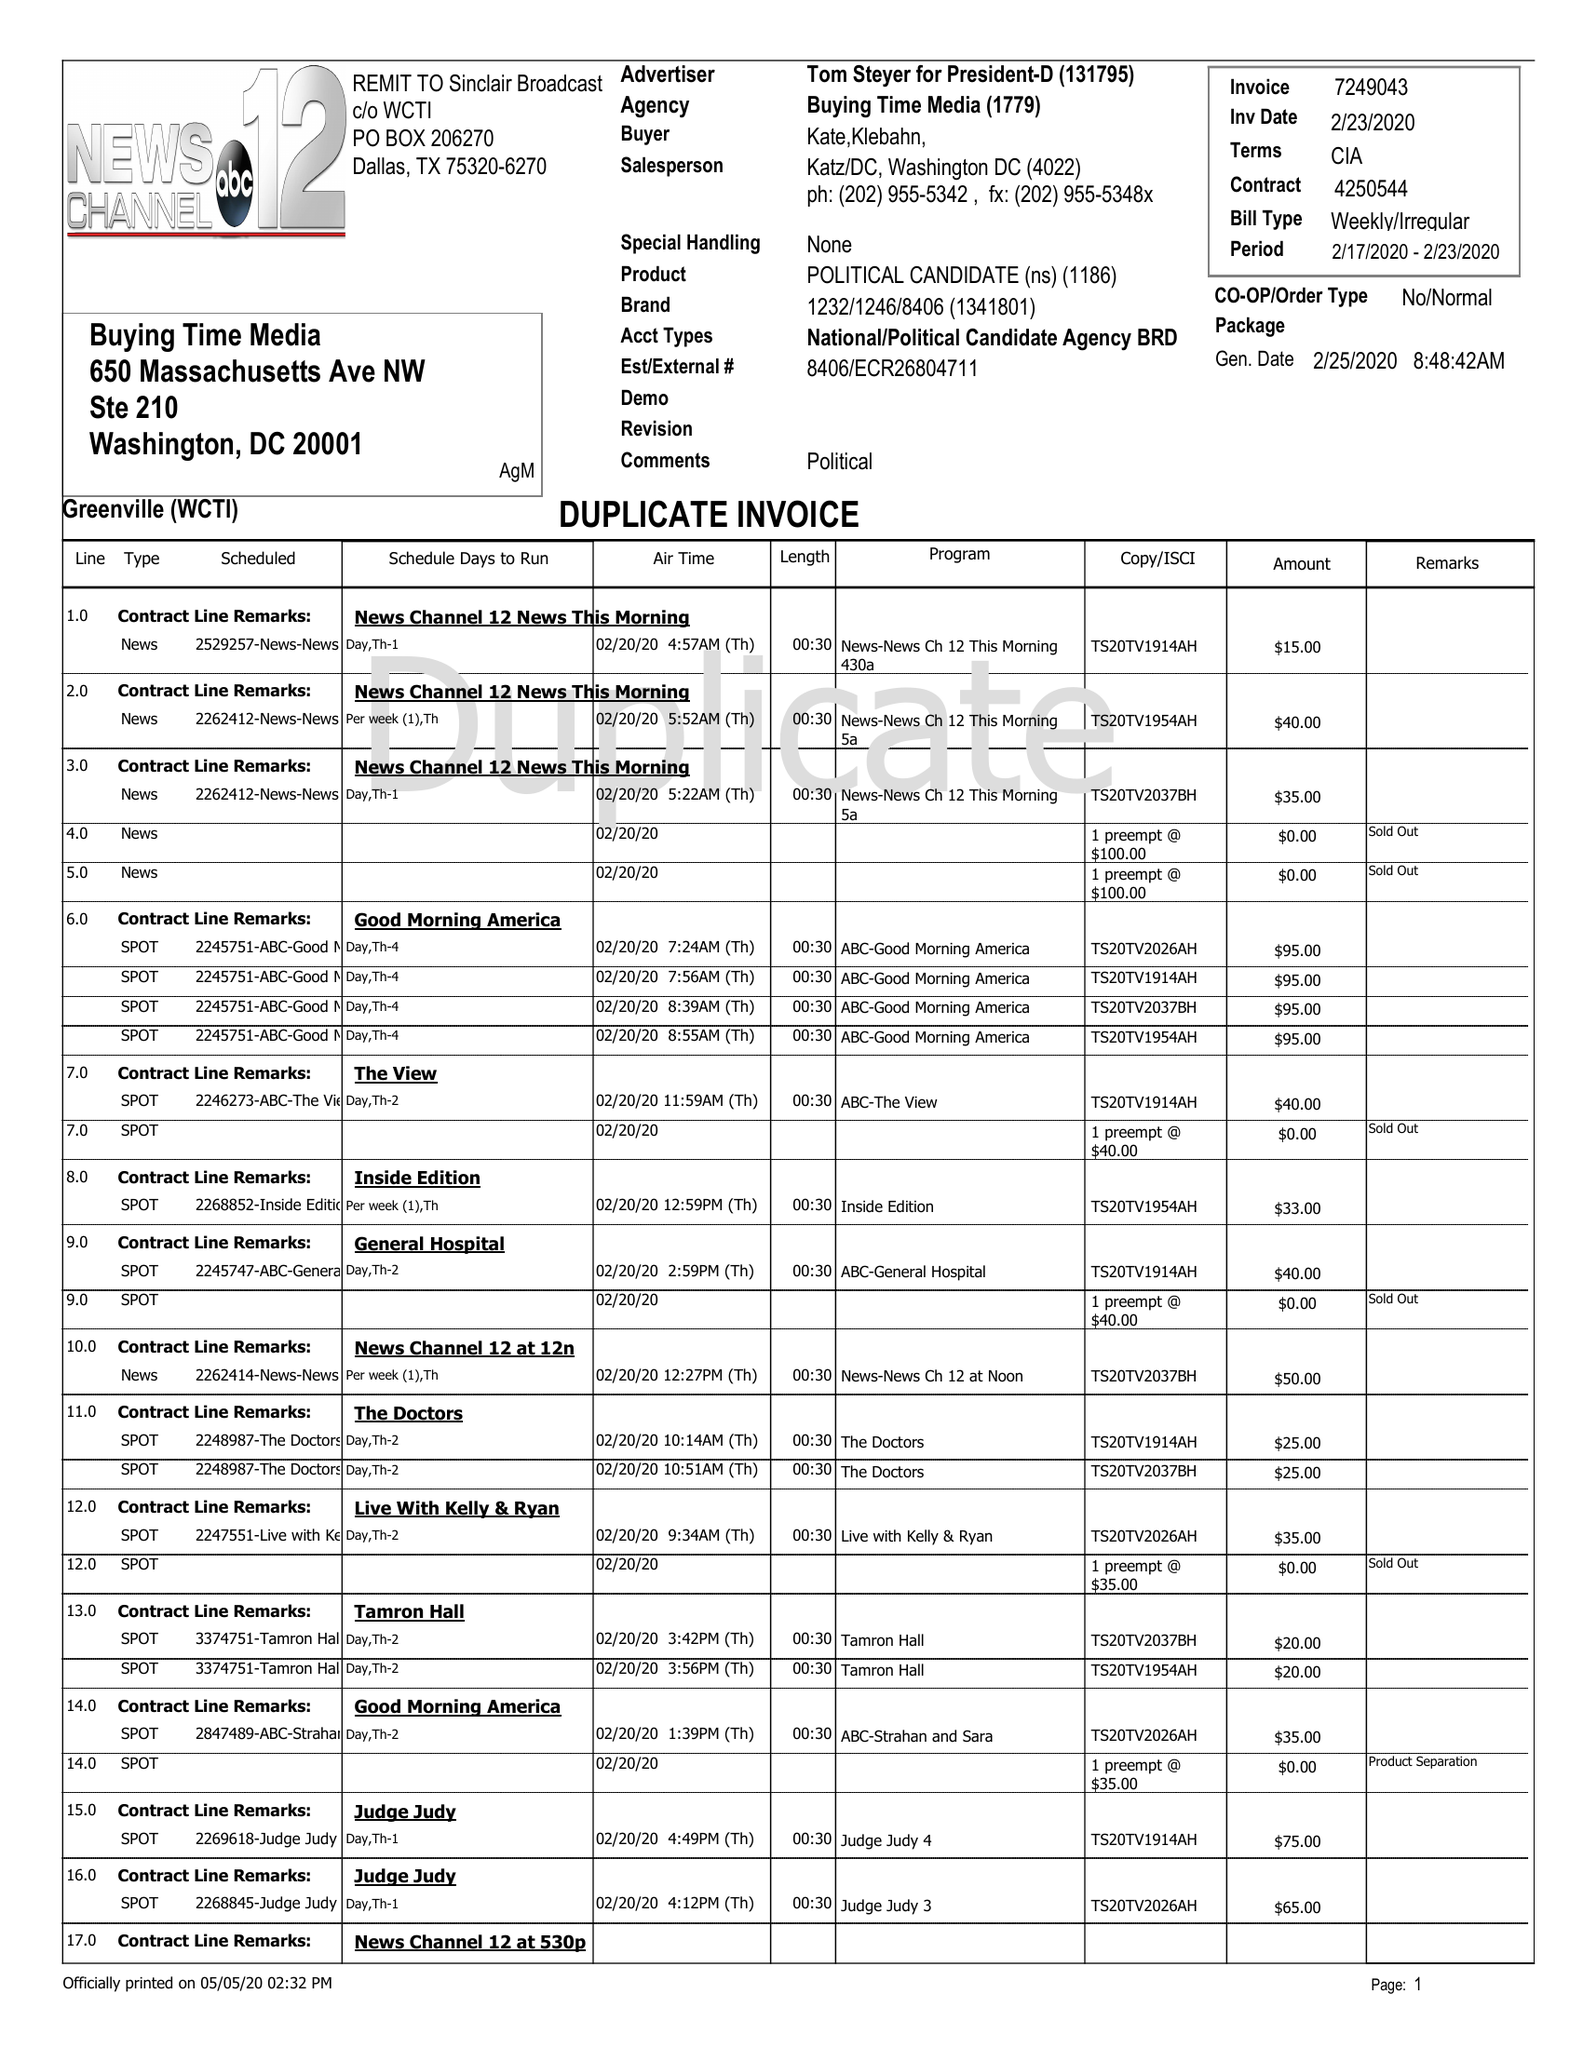What is the value for the contract_num?
Answer the question using a single word or phrase. 4250544 